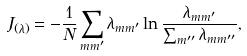<formula> <loc_0><loc_0><loc_500><loc_500>J _ { ( \lambda ) } = - \frac { 1 } { N } \sum _ { m m ^ { \prime } } \lambda _ { m m ^ { \prime } } \ln \frac { \lambda _ { m m ^ { \prime } } } { \sum _ { m ^ { \prime \prime } } \lambda _ { m m ^ { \prime \prime } } } ,</formula> 